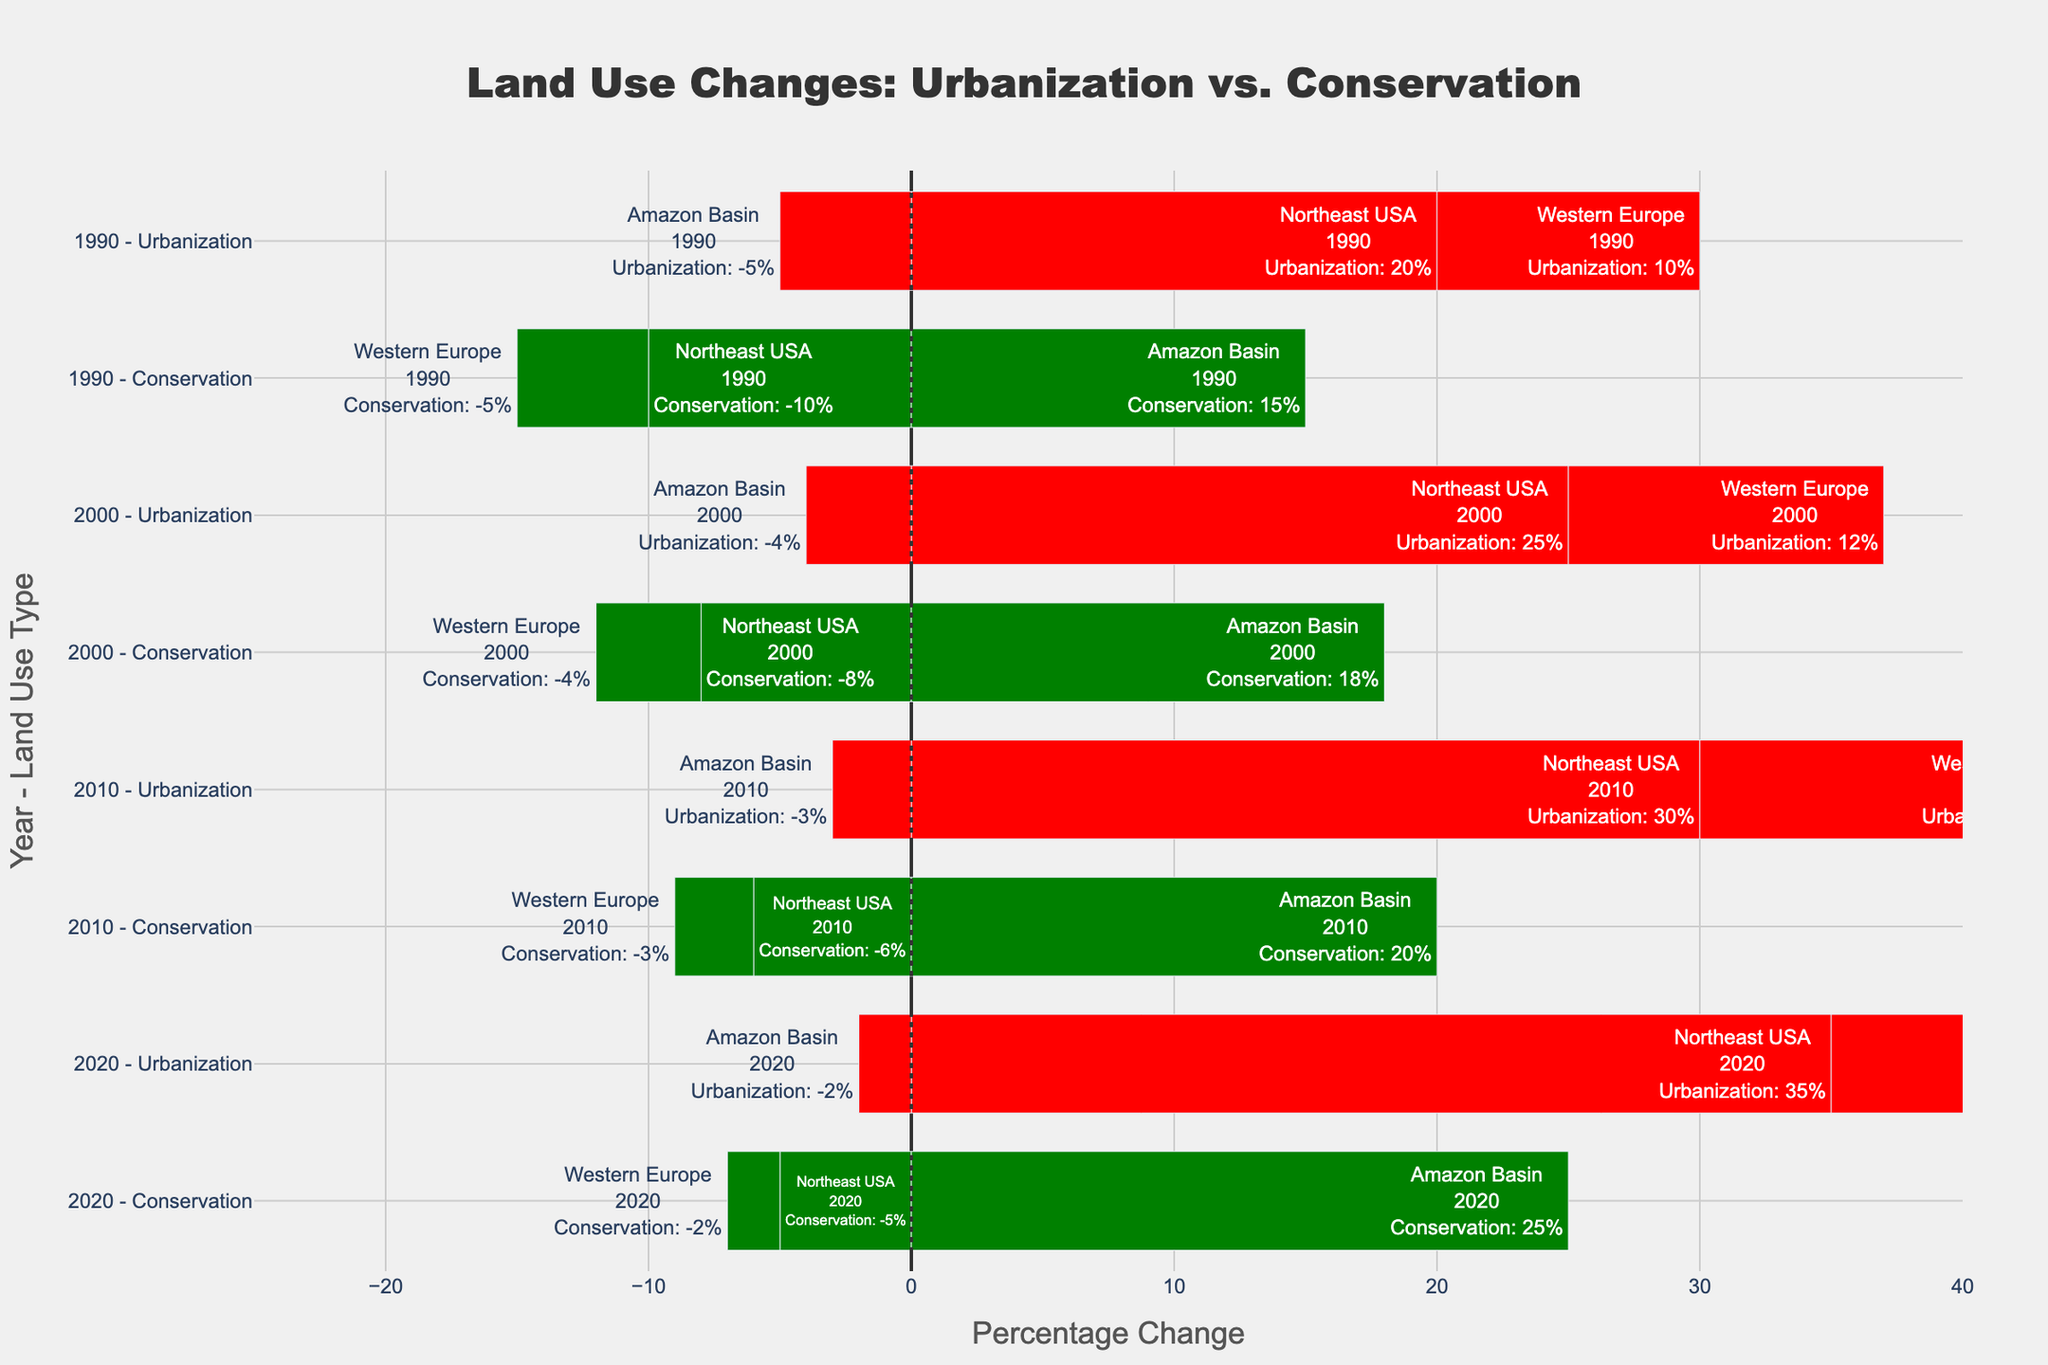Which year shows the maximum difference in percentage change between Urbanization and Conservation in the Northeast USA? To find the maximum difference, calculate the difference between Urbanization and Conservation percentages for each year in the Northeast USA and compare them. The differences are as follows: 1990 (20 - (-10) = 30), 2000 (25 - (-8) = 33), 2010 (30 - (-6) = 36), 2020 (35 - (-5) = 40). The year with the maximum difference is 2020.
Answer: 2020 How did the Conservation percentage change in the Amazon Basin from 1990 to 2020? Compare the Conservation percentages in the Amazon Basin for the years 1990 and 2020. In 1990, the value is 15%, and in 2020, it is 25%. The change is 25 - 15 = 10 percentage points.
Answer: 10 percentage points Is there any year where Western Europe saw no change in Conservation percentage compared to the previous recorded year? Check the Conservation percentage for Western Europe from one recorded year to the next. The following changes are observed: 1990 (-5%), 2000 (-4%), 2010 (-3%), and 2020 (-2%). None of these changes are zero.
Answer: No What is the overall trend of Urbanization in the Northeast USA over the decades? Observe the Urbanization percentage changes for the Northeast USA over the years 1990 (20%), 2000 (25%), 2010 (30%), and 2020 (35%). The values show a consistent increase over the years.
Answer: Increasing Which region had the least urbanization increase in 2020? Compare the Urbanization percentage changes for the three regions in 2020. The values are: Northeast USA (35%), Amazon Basin (-2%), and Western Europe (18%). The Amazon Basin had a negative urbanization change, indicating it had the least increase.
Answer: Amazon Basin What is the total percentage change in Conservation efforts for all regions combined in 2010? Sum the Conservation percentage changes for 2010 for all regions: Northeast USA (-6), Amazon Basin (20), Western Europe (-3). The total is -6 + 20 - 3 = 11.
Answer: 11 Did any region experience a negative percentage change in Urbanization in 1990? Check the Urbanization percentage changes for 1990 for all regions: Northeast USA (20%), Amazon Basin (-5%), Western Europe (10%). The Amazon Basin has a negative change.
Answer: Amazon Basin By how much did the Conservation percentage change differ between the Amazon Basin and Western Europe in 2000? Calculate the difference between the Conservation percentages for the Amazon Basin (18%) and Western Europe (-4%) in 2000. The difference is 18 - (-4) = 22 percentage points.
Answer: 22 percentage points How did the Amazon Basin's Urbanization change compare from 1990 to 2020? Check the Urbanization percentages for the Amazon Basin in 1990 (-5%) and 2020 (-2%). The change is -2 - (-5) = 3 percentage points increase.
Answer: 3 percentage points increase 